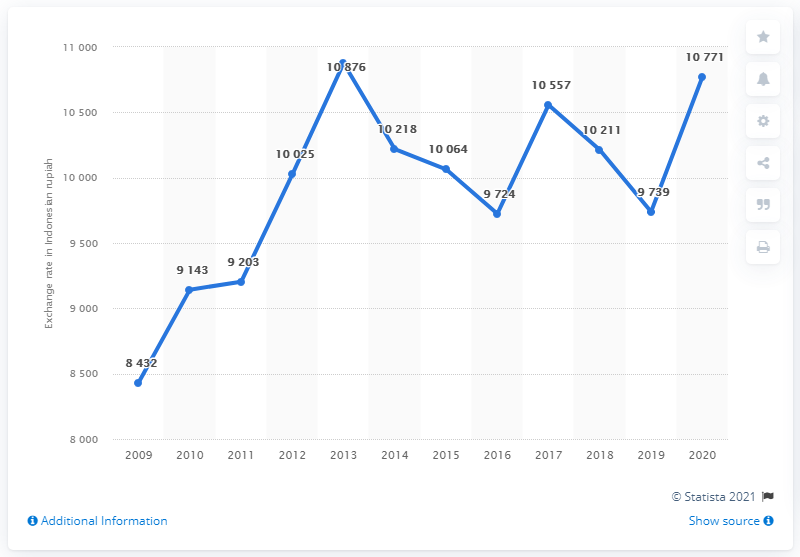Mention a couple of crucial points in this snapshot. In 2020, the average exchange rate from Indonesian rupiah to Australian dollars was 107,710 Indonesian rupiah to Australian dollars. In 2020, the average exchange rate from Indonesian rupiah to Australian dollars was 10,771 Indonesian rupiah to Australian dollars. 